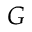<formula> <loc_0><loc_0><loc_500><loc_500>G</formula> 